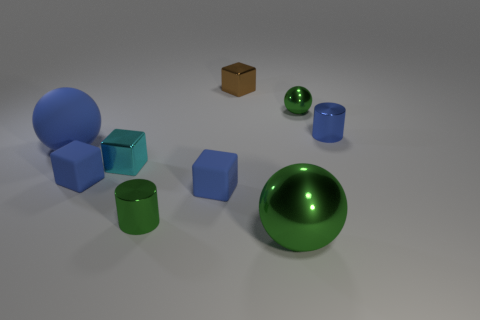Subtract all brown spheres. Subtract all cyan cylinders. How many spheres are left? 3 Add 1 tiny matte objects. How many objects exist? 10 Subtract all blocks. How many objects are left? 5 Add 2 big metallic things. How many big metallic things exist? 3 Subtract 0 red blocks. How many objects are left? 9 Subtract all matte things. Subtract all small brown metal blocks. How many objects are left? 5 Add 4 tiny blue cylinders. How many tiny blue cylinders are left? 5 